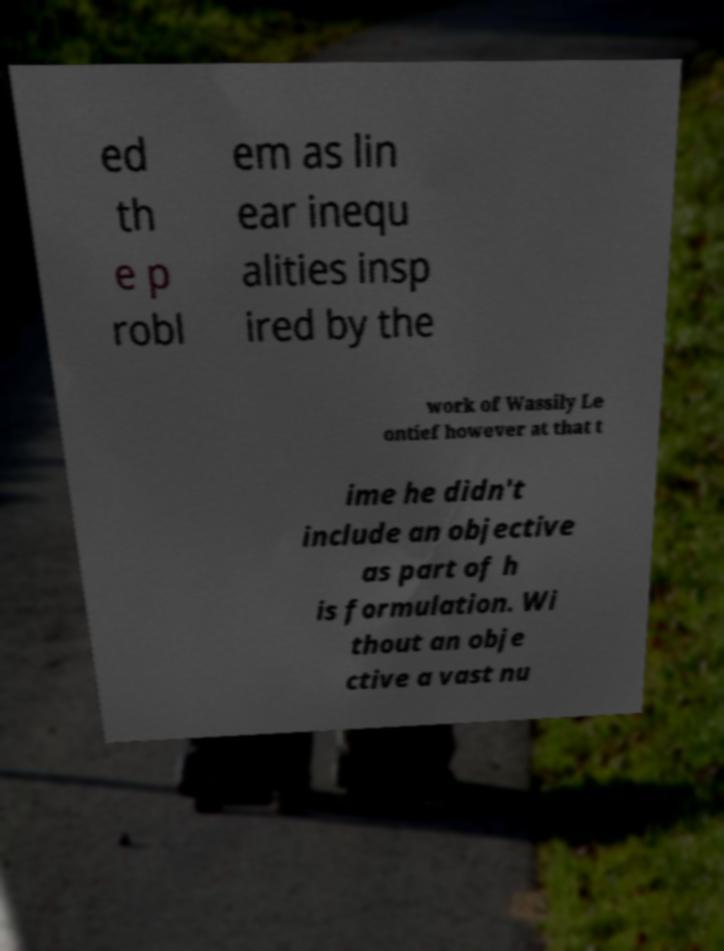Could you extract and type out the text from this image? ed th e p robl em as lin ear inequ alities insp ired by the work of Wassily Le ontief however at that t ime he didn't include an objective as part of h is formulation. Wi thout an obje ctive a vast nu 